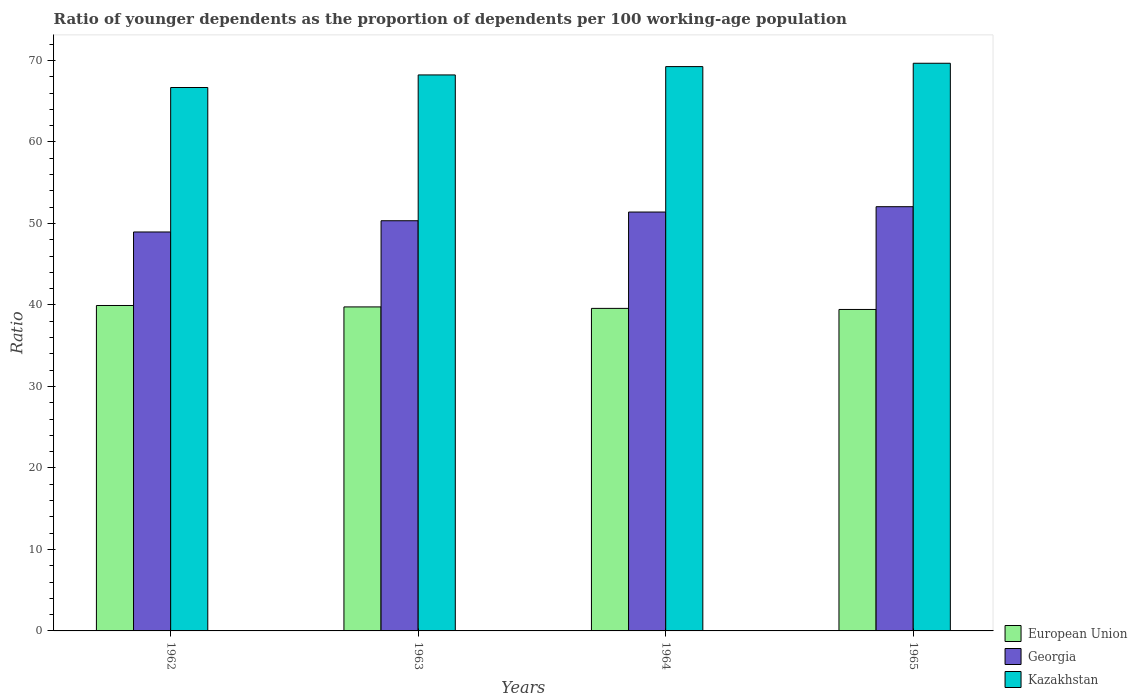How many different coloured bars are there?
Give a very brief answer. 3. Are the number of bars on each tick of the X-axis equal?
Offer a terse response. Yes. How many bars are there on the 3rd tick from the left?
Make the answer very short. 3. How many bars are there on the 1st tick from the right?
Provide a succinct answer. 3. In how many cases, is the number of bars for a given year not equal to the number of legend labels?
Give a very brief answer. 0. What is the age dependency ratio(young) in European Union in 1962?
Keep it short and to the point. 39.93. Across all years, what is the maximum age dependency ratio(young) in Georgia?
Make the answer very short. 52.05. Across all years, what is the minimum age dependency ratio(young) in European Union?
Provide a succinct answer. 39.44. In which year was the age dependency ratio(young) in European Union minimum?
Provide a short and direct response. 1965. What is the total age dependency ratio(young) in European Union in the graph?
Your answer should be very brief. 158.7. What is the difference between the age dependency ratio(young) in Georgia in 1962 and that in 1964?
Give a very brief answer. -2.45. What is the difference between the age dependency ratio(young) in Georgia in 1962 and the age dependency ratio(young) in Kazakhstan in 1963?
Provide a short and direct response. -19.27. What is the average age dependency ratio(young) in European Union per year?
Provide a succinct answer. 39.67. In the year 1963, what is the difference between the age dependency ratio(young) in Georgia and age dependency ratio(young) in European Union?
Ensure brevity in your answer.  10.57. In how many years, is the age dependency ratio(young) in Kazakhstan greater than 14?
Your response must be concise. 4. What is the ratio of the age dependency ratio(young) in European Union in 1964 to that in 1965?
Your answer should be very brief. 1. Is the age dependency ratio(young) in European Union in 1962 less than that in 1963?
Ensure brevity in your answer.  No. What is the difference between the highest and the second highest age dependency ratio(young) in European Union?
Your answer should be very brief. 0.17. What is the difference between the highest and the lowest age dependency ratio(young) in European Union?
Your response must be concise. 0.49. Is the sum of the age dependency ratio(young) in Kazakhstan in 1962 and 1963 greater than the maximum age dependency ratio(young) in Georgia across all years?
Provide a succinct answer. Yes. What does the 3rd bar from the left in 1964 represents?
Ensure brevity in your answer.  Kazakhstan. What does the 1st bar from the right in 1965 represents?
Your response must be concise. Kazakhstan. Are all the bars in the graph horizontal?
Your answer should be very brief. No. What is the difference between two consecutive major ticks on the Y-axis?
Give a very brief answer. 10. How many legend labels are there?
Make the answer very short. 3. How are the legend labels stacked?
Your response must be concise. Vertical. What is the title of the graph?
Ensure brevity in your answer.  Ratio of younger dependents as the proportion of dependents per 100 working-age population. What is the label or title of the X-axis?
Your response must be concise. Years. What is the label or title of the Y-axis?
Offer a very short reply. Ratio. What is the Ratio in European Union in 1962?
Your answer should be compact. 39.93. What is the Ratio in Georgia in 1962?
Ensure brevity in your answer.  48.95. What is the Ratio of Kazakhstan in 1962?
Offer a very short reply. 66.67. What is the Ratio in European Union in 1963?
Give a very brief answer. 39.75. What is the Ratio of Georgia in 1963?
Offer a very short reply. 50.33. What is the Ratio of Kazakhstan in 1963?
Ensure brevity in your answer.  68.22. What is the Ratio of European Union in 1964?
Offer a terse response. 39.57. What is the Ratio of Georgia in 1964?
Provide a short and direct response. 51.4. What is the Ratio of Kazakhstan in 1964?
Your response must be concise. 69.24. What is the Ratio of European Union in 1965?
Offer a terse response. 39.44. What is the Ratio of Georgia in 1965?
Your answer should be very brief. 52.05. What is the Ratio in Kazakhstan in 1965?
Your response must be concise. 69.65. Across all years, what is the maximum Ratio in European Union?
Your answer should be compact. 39.93. Across all years, what is the maximum Ratio of Georgia?
Ensure brevity in your answer.  52.05. Across all years, what is the maximum Ratio of Kazakhstan?
Ensure brevity in your answer.  69.65. Across all years, what is the minimum Ratio in European Union?
Your answer should be compact. 39.44. Across all years, what is the minimum Ratio in Georgia?
Ensure brevity in your answer.  48.95. Across all years, what is the minimum Ratio in Kazakhstan?
Make the answer very short. 66.67. What is the total Ratio of European Union in the graph?
Keep it short and to the point. 158.7. What is the total Ratio in Georgia in the graph?
Provide a succinct answer. 202.72. What is the total Ratio in Kazakhstan in the graph?
Keep it short and to the point. 273.78. What is the difference between the Ratio of European Union in 1962 and that in 1963?
Make the answer very short. 0.17. What is the difference between the Ratio in Georgia in 1962 and that in 1963?
Your response must be concise. -1.38. What is the difference between the Ratio in Kazakhstan in 1962 and that in 1963?
Make the answer very short. -1.54. What is the difference between the Ratio of European Union in 1962 and that in 1964?
Provide a succinct answer. 0.36. What is the difference between the Ratio in Georgia in 1962 and that in 1964?
Provide a succinct answer. -2.45. What is the difference between the Ratio of Kazakhstan in 1962 and that in 1964?
Provide a short and direct response. -2.57. What is the difference between the Ratio of European Union in 1962 and that in 1965?
Give a very brief answer. 0.49. What is the difference between the Ratio in Georgia in 1962 and that in 1965?
Offer a very short reply. -3.1. What is the difference between the Ratio in Kazakhstan in 1962 and that in 1965?
Your answer should be very brief. -2.98. What is the difference between the Ratio in European Union in 1963 and that in 1964?
Ensure brevity in your answer.  0.18. What is the difference between the Ratio in Georgia in 1963 and that in 1964?
Offer a terse response. -1.07. What is the difference between the Ratio of Kazakhstan in 1963 and that in 1964?
Make the answer very short. -1.02. What is the difference between the Ratio in European Union in 1963 and that in 1965?
Keep it short and to the point. 0.31. What is the difference between the Ratio in Georgia in 1963 and that in 1965?
Make the answer very short. -1.72. What is the difference between the Ratio of Kazakhstan in 1963 and that in 1965?
Keep it short and to the point. -1.43. What is the difference between the Ratio in European Union in 1964 and that in 1965?
Your answer should be very brief. 0.13. What is the difference between the Ratio of Georgia in 1964 and that in 1965?
Provide a succinct answer. -0.66. What is the difference between the Ratio of Kazakhstan in 1964 and that in 1965?
Keep it short and to the point. -0.41. What is the difference between the Ratio in European Union in 1962 and the Ratio in Georgia in 1963?
Provide a succinct answer. -10.4. What is the difference between the Ratio in European Union in 1962 and the Ratio in Kazakhstan in 1963?
Your response must be concise. -28.29. What is the difference between the Ratio of Georgia in 1962 and the Ratio of Kazakhstan in 1963?
Give a very brief answer. -19.27. What is the difference between the Ratio of European Union in 1962 and the Ratio of Georgia in 1964?
Make the answer very short. -11.47. What is the difference between the Ratio of European Union in 1962 and the Ratio of Kazakhstan in 1964?
Make the answer very short. -29.31. What is the difference between the Ratio of Georgia in 1962 and the Ratio of Kazakhstan in 1964?
Offer a very short reply. -20.29. What is the difference between the Ratio in European Union in 1962 and the Ratio in Georgia in 1965?
Provide a short and direct response. -12.12. What is the difference between the Ratio of European Union in 1962 and the Ratio of Kazakhstan in 1965?
Give a very brief answer. -29.72. What is the difference between the Ratio of Georgia in 1962 and the Ratio of Kazakhstan in 1965?
Ensure brevity in your answer.  -20.7. What is the difference between the Ratio of European Union in 1963 and the Ratio of Georgia in 1964?
Your answer should be compact. -11.64. What is the difference between the Ratio in European Union in 1963 and the Ratio in Kazakhstan in 1964?
Your answer should be very brief. -29.49. What is the difference between the Ratio in Georgia in 1963 and the Ratio in Kazakhstan in 1964?
Your answer should be very brief. -18.91. What is the difference between the Ratio in European Union in 1963 and the Ratio in Georgia in 1965?
Offer a very short reply. -12.3. What is the difference between the Ratio of European Union in 1963 and the Ratio of Kazakhstan in 1965?
Your response must be concise. -29.9. What is the difference between the Ratio of Georgia in 1963 and the Ratio of Kazakhstan in 1965?
Give a very brief answer. -19.32. What is the difference between the Ratio in European Union in 1964 and the Ratio in Georgia in 1965?
Provide a succinct answer. -12.48. What is the difference between the Ratio of European Union in 1964 and the Ratio of Kazakhstan in 1965?
Give a very brief answer. -30.08. What is the difference between the Ratio in Georgia in 1964 and the Ratio in Kazakhstan in 1965?
Offer a very short reply. -18.26. What is the average Ratio in European Union per year?
Your answer should be compact. 39.67. What is the average Ratio of Georgia per year?
Offer a very short reply. 50.68. What is the average Ratio of Kazakhstan per year?
Ensure brevity in your answer.  68.45. In the year 1962, what is the difference between the Ratio of European Union and Ratio of Georgia?
Your answer should be very brief. -9.02. In the year 1962, what is the difference between the Ratio of European Union and Ratio of Kazakhstan?
Your answer should be very brief. -26.75. In the year 1962, what is the difference between the Ratio in Georgia and Ratio in Kazakhstan?
Provide a succinct answer. -17.73. In the year 1963, what is the difference between the Ratio in European Union and Ratio in Georgia?
Make the answer very short. -10.57. In the year 1963, what is the difference between the Ratio of European Union and Ratio of Kazakhstan?
Provide a succinct answer. -28.46. In the year 1963, what is the difference between the Ratio of Georgia and Ratio of Kazakhstan?
Keep it short and to the point. -17.89. In the year 1964, what is the difference between the Ratio of European Union and Ratio of Georgia?
Your answer should be very brief. -11.82. In the year 1964, what is the difference between the Ratio in European Union and Ratio in Kazakhstan?
Keep it short and to the point. -29.67. In the year 1964, what is the difference between the Ratio in Georgia and Ratio in Kazakhstan?
Your answer should be compact. -17.85. In the year 1965, what is the difference between the Ratio of European Union and Ratio of Georgia?
Keep it short and to the point. -12.61. In the year 1965, what is the difference between the Ratio in European Union and Ratio in Kazakhstan?
Give a very brief answer. -30.21. In the year 1965, what is the difference between the Ratio of Georgia and Ratio of Kazakhstan?
Offer a very short reply. -17.6. What is the ratio of the Ratio of Georgia in 1962 to that in 1963?
Keep it short and to the point. 0.97. What is the ratio of the Ratio in Kazakhstan in 1962 to that in 1963?
Offer a terse response. 0.98. What is the ratio of the Ratio in European Union in 1962 to that in 1964?
Provide a succinct answer. 1.01. What is the ratio of the Ratio of Kazakhstan in 1962 to that in 1964?
Keep it short and to the point. 0.96. What is the ratio of the Ratio of European Union in 1962 to that in 1965?
Your answer should be very brief. 1.01. What is the ratio of the Ratio of Georgia in 1962 to that in 1965?
Ensure brevity in your answer.  0.94. What is the ratio of the Ratio in Kazakhstan in 1962 to that in 1965?
Offer a very short reply. 0.96. What is the ratio of the Ratio in Georgia in 1963 to that in 1964?
Give a very brief answer. 0.98. What is the ratio of the Ratio in Kazakhstan in 1963 to that in 1964?
Offer a very short reply. 0.99. What is the ratio of the Ratio in European Union in 1963 to that in 1965?
Give a very brief answer. 1.01. What is the ratio of the Ratio of Georgia in 1963 to that in 1965?
Your answer should be compact. 0.97. What is the ratio of the Ratio in Kazakhstan in 1963 to that in 1965?
Offer a very short reply. 0.98. What is the ratio of the Ratio in Georgia in 1964 to that in 1965?
Make the answer very short. 0.99. What is the ratio of the Ratio in Kazakhstan in 1964 to that in 1965?
Ensure brevity in your answer.  0.99. What is the difference between the highest and the second highest Ratio of European Union?
Offer a terse response. 0.17. What is the difference between the highest and the second highest Ratio in Georgia?
Provide a succinct answer. 0.66. What is the difference between the highest and the second highest Ratio in Kazakhstan?
Offer a very short reply. 0.41. What is the difference between the highest and the lowest Ratio in European Union?
Your answer should be compact. 0.49. What is the difference between the highest and the lowest Ratio of Georgia?
Your answer should be very brief. 3.1. What is the difference between the highest and the lowest Ratio in Kazakhstan?
Provide a succinct answer. 2.98. 